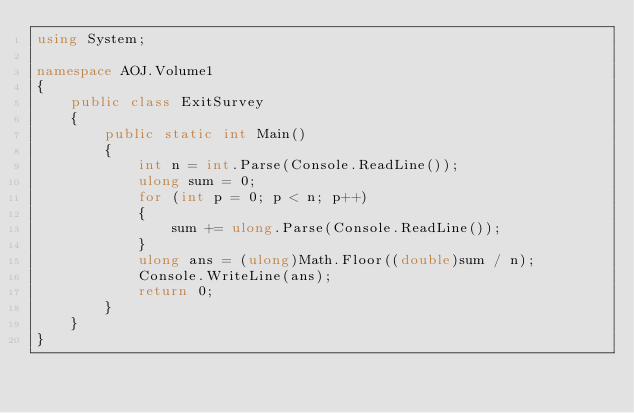<code> <loc_0><loc_0><loc_500><loc_500><_C#_>using System;

namespace AOJ.Volume1
{
    public class ExitSurvey
    {
        public static int Main()
        {
            int n = int.Parse(Console.ReadLine());
            ulong sum = 0;
            for (int p = 0; p < n; p++)
            {
                sum += ulong.Parse(Console.ReadLine());
            }
            ulong ans = (ulong)Math.Floor((double)sum / n);
            Console.WriteLine(ans);
            return 0;
        }
    }
}</code> 